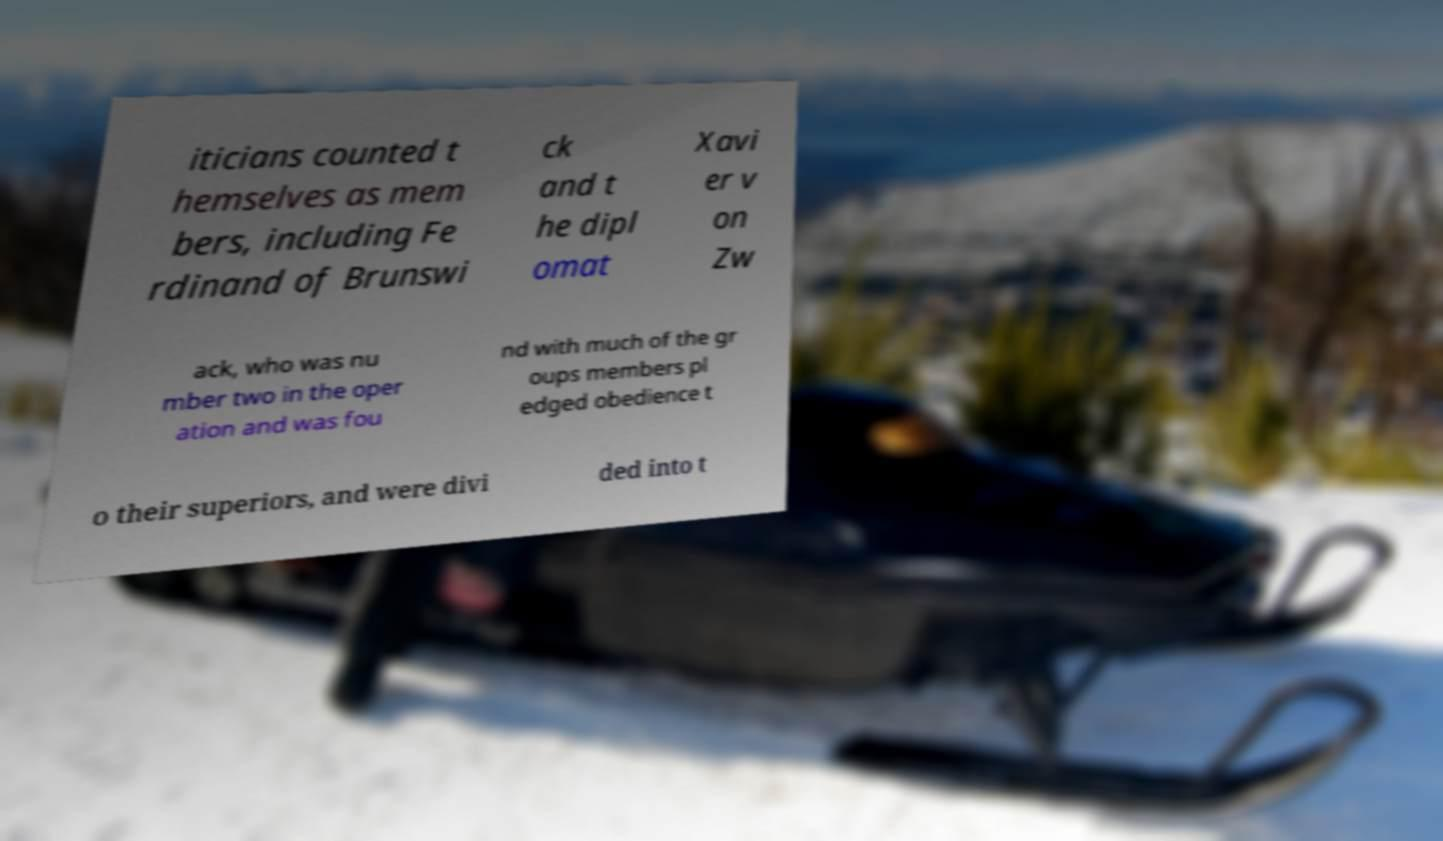Can you accurately transcribe the text from the provided image for me? iticians counted t hemselves as mem bers, including Fe rdinand of Brunswi ck and t he dipl omat Xavi er v on Zw ack, who was nu mber two in the oper ation and was fou nd with much of the gr oups members pl edged obedience t o their superiors, and were divi ded into t 